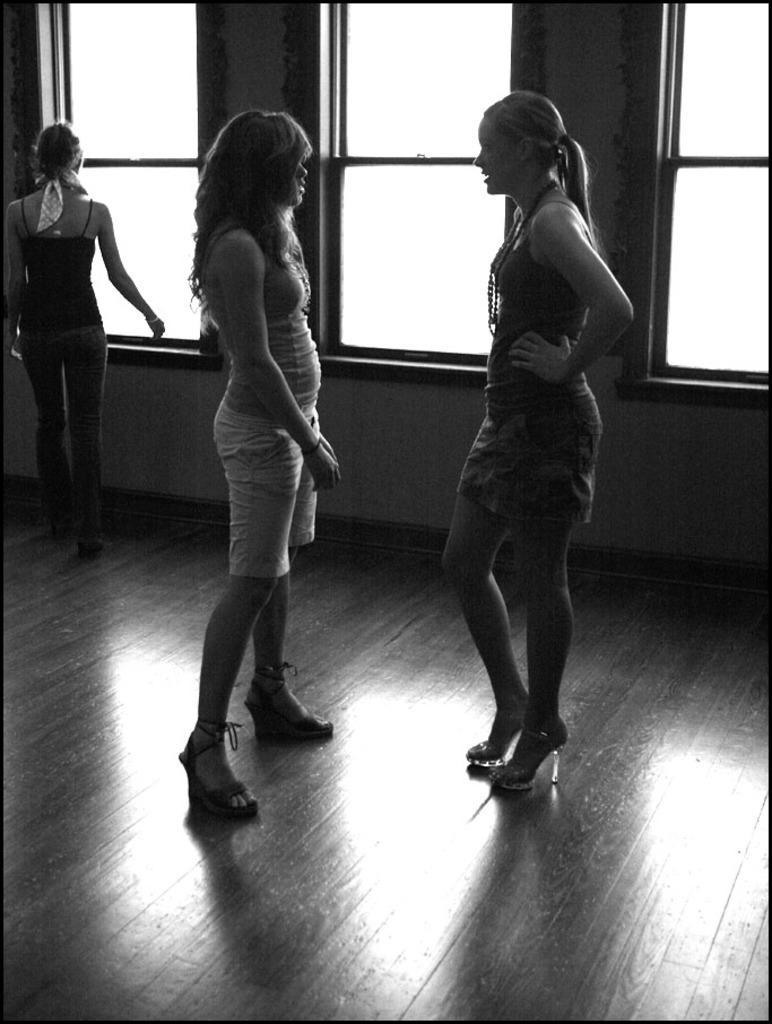Describe this image in one or two sentences. In this picture there are two girls in the center of the image and there is another girl on the left side of the image, there are windows in the background area of the image. 